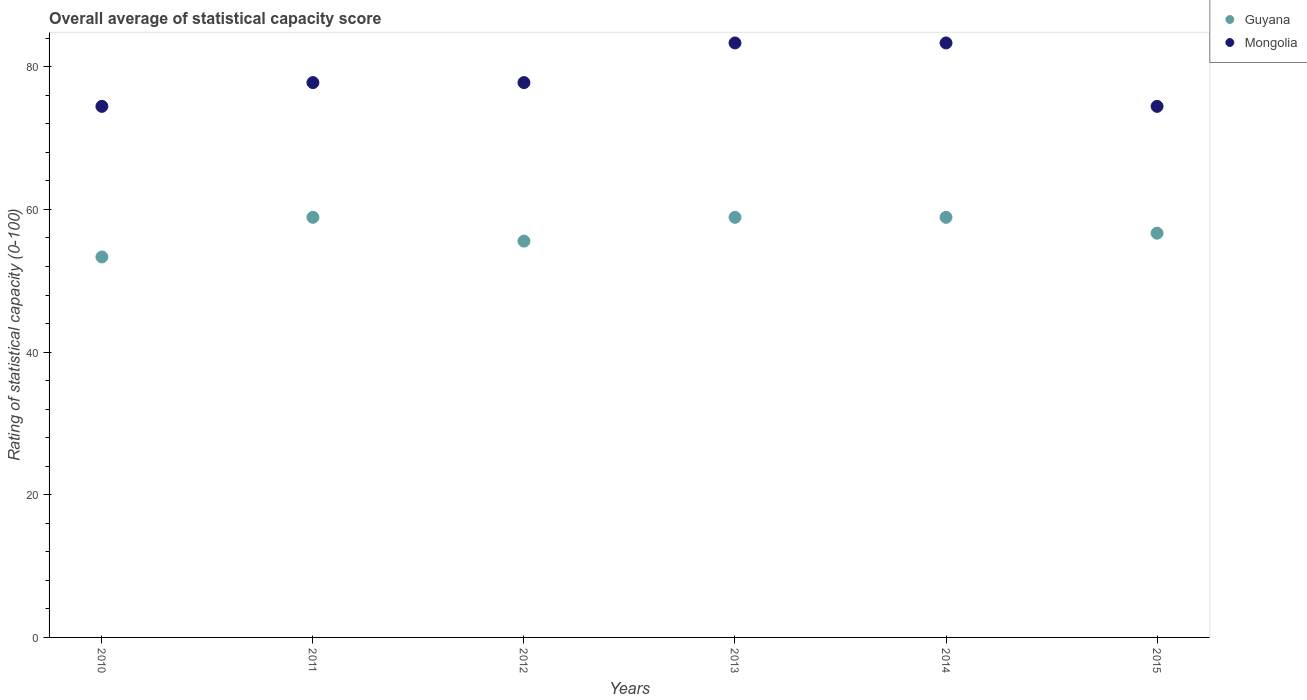What is the rating of statistical capacity in Mongolia in 2014?
Your response must be concise. 83.33. Across all years, what is the maximum rating of statistical capacity in Mongolia?
Keep it short and to the point. 83.33. Across all years, what is the minimum rating of statistical capacity in Mongolia?
Your answer should be very brief. 74.44. What is the total rating of statistical capacity in Mongolia in the graph?
Offer a very short reply. 471.11. What is the difference between the rating of statistical capacity in Guyana in 2010 and that in 2014?
Offer a very short reply. -5.56. What is the difference between the rating of statistical capacity in Guyana in 2011 and the rating of statistical capacity in Mongolia in 2012?
Make the answer very short. -18.89. What is the average rating of statistical capacity in Guyana per year?
Provide a short and direct response. 57.04. In the year 2012, what is the difference between the rating of statistical capacity in Mongolia and rating of statistical capacity in Guyana?
Ensure brevity in your answer.  22.22. What is the ratio of the rating of statistical capacity in Mongolia in 2014 to that in 2015?
Provide a short and direct response. 1.12. Is the rating of statistical capacity in Guyana in 2014 less than that in 2015?
Make the answer very short. No. Is the difference between the rating of statistical capacity in Mongolia in 2012 and 2014 greater than the difference between the rating of statistical capacity in Guyana in 2012 and 2014?
Keep it short and to the point. No. What is the difference between the highest and the second highest rating of statistical capacity in Mongolia?
Ensure brevity in your answer.  0. What is the difference between the highest and the lowest rating of statistical capacity in Mongolia?
Offer a terse response. 8.89. In how many years, is the rating of statistical capacity in Guyana greater than the average rating of statistical capacity in Guyana taken over all years?
Keep it short and to the point. 3. Is the sum of the rating of statistical capacity in Guyana in 2012 and 2015 greater than the maximum rating of statistical capacity in Mongolia across all years?
Offer a very short reply. Yes. Does the rating of statistical capacity in Mongolia monotonically increase over the years?
Your answer should be compact. No. Is the rating of statistical capacity in Guyana strictly less than the rating of statistical capacity in Mongolia over the years?
Your answer should be compact. Yes. How many dotlines are there?
Ensure brevity in your answer.  2. How many years are there in the graph?
Offer a very short reply. 6. Does the graph contain grids?
Your answer should be compact. No. How many legend labels are there?
Your answer should be very brief. 2. What is the title of the graph?
Give a very brief answer. Overall average of statistical capacity score. What is the label or title of the Y-axis?
Give a very brief answer. Rating of statistical capacity (0-100). What is the Rating of statistical capacity (0-100) of Guyana in 2010?
Your answer should be very brief. 53.33. What is the Rating of statistical capacity (0-100) in Mongolia in 2010?
Provide a succinct answer. 74.44. What is the Rating of statistical capacity (0-100) of Guyana in 2011?
Your answer should be very brief. 58.89. What is the Rating of statistical capacity (0-100) of Mongolia in 2011?
Ensure brevity in your answer.  77.78. What is the Rating of statistical capacity (0-100) of Guyana in 2012?
Your response must be concise. 55.56. What is the Rating of statistical capacity (0-100) in Mongolia in 2012?
Provide a succinct answer. 77.78. What is the Rating of statistical capacity (0-100) in Guyana in 2013?
Keep it short and to the point. 58.89. What is the Rating of statistical capacity (0-100) in Mongolia in 2013?
Provide a succinct answer. 83.33. What is the Rating of statistical capacity (0-100) of Guyana in 2014?
Your answer should be very brief. 58.89. What is the Rating of statistical capacity (0-100) in Mongolia in 2014?
Ensure brevity in your answer.  83.33. What is the Rating of statistical capacity (0-100) in Guyana in 2015?
Make the answer very short. 56.67. What is the Rating of statistical capacity (0-100) of Mongolia in 2015?
Make the answer very short. 74.44. Across all years, what is the maximum Rating of statistical capacity (0-100) of Guyana?
Your response must be concise. 58.89. Across all years, what is the maximum Rating of statistical capacity (0-100) in Mongolia?
Give a very brief answer. 83.33. Across all years, what is the minimum Rating of statistical capacity (0-100) in Guyana?
Your response must be concise. 53.33. Across all years, what is the minimum Rating of statistical capacity (0-100) of Mongolia?
Provide a short and direct response. 74.44. What is the total Rating of statistical capacity (0-100) in Guyana in the graph?
Your answer should be compact. 342.22. What is the total Rating of statistical capacity (0-100) in Mongolia in the graph?
Offer a terse response. 471.11. What is the difference between the Rating of statistical capacity (0-100) of Guyana in 2010 and that in 2011?
Offer a very short reply. -5.56. What is the difference between the Rating of statistical capacity (0-100) of Mongolia in 2010 and that in 2011?
Offer a very short reply. -3.33. What is the difference between the Rating of statistical capacity (0-100) in Guyana in 2010 and that in 2012?
Ensure brevity in your answer.  -2.22. What is the difference between the Rating of statistical capacity (0-100) in Mongolia in 2010 and that in 2012?
Your answer should be compact. -3.33. What is the difference between the Rating of statistical capacity (0-100) in Guyana in 2010 and that in 2013?
Your answer should be very brief. -5.56. What is the difference between the Rating of statistical capacity (0-100) in Mongolia in 2010 and that in 2013?
Provide a succinct answer. -8.89. What is the difference between the Rating of statistical capacity (0-100) in Guyana in 2010 and that in 2014?
Give a very brief answer. -5.56. What is the difference between the Rating of statistical capacity (0-100) of Mongolia in 2010 and that in 2014?
Give a very brief answer. -8.89. What is the difference between the Rating of statistical capacity (0-100) in Guyana in 2010 and that in 2015?
Provide a succinct answer. -3.33. What is the difference between the Rating of statistical capacity (0-100) of Mongolia in 2010 and that in 2015?
Offer a terse response. 0. What is the difference between the Rating of statistical capacity (0-100) in Guyana in 2011 and that in 2012?
Keep it short and to the point. 3.33. What is the difference between the Rating of statistical capacity (0-100) in Mongolia in 2011 and that in 2012?
Offer a very short reply. 0. What is the difference between the Rating of statistical capacity (0-100) of Mongolia in 2011 and that in 2013?
Ensure brevity in your answer.  -5.56. What is the difference between the Rating of statistical capacity (0-100) of Mongolia in 2011 and that in 2014?
Keep it short and to the point. -5.56. What is the difference between the Rating of statistical capacity (0-100) in Guyana in 2011 and that in 2015?
Provide a succinct answer. 2.22. What is the difference between the Rating of statistical capacity (0-100) of Mongolia in 2011 and that in 2015?
Make the answer very short. 3.33. What is the difference between the Rating of statistical capacity (0-100) of Guyana in 2012 and that in 2013?
Offer a very short reply. -3.33. What is the difference between the Rating of statistical capacity (0-100) of Mongolia in 2012 and that in 2013?
Keep it short and to the point. -5.56. What is the difference between the Rating of statistical capacity (0-100) in Mongolia in 2012 and that in 2014?
Give a very brief answer. -5.56. What is the difference between the Rating of statistical capacity (0-100) of Guyana in 2012 and that in 2015?
Provide a short and direct response. -1.11. What is the difference between the Rating of statistical capacity (0-100) of Mongolia in 2012 and that in 2015?
Ensure brevity in your answer.  3.33. What is the difference between the Rating of statistical capacity (0-100) of Guyana in 2013 and that in 2015?
Offer a terse response. 2.22. What is the difference between the Rating of statistical capacity (0-100) in Mongolia in 2013 and that in 2015?
Make the answer very short. 8.89. What is the difference between the Rating of statistical capacity (0-100) of Guyana in 2014 and that in 2015?
Keep it short and to the point. 2.22. What is the difference between the Rating of statistical capacity (0-100) in Mongolia in 2014 and that in 2015?
Keep it short and to the point. 8.89. What is the difference between the Rating of statistical capacity (0-100) in Guyana in 2010 and the Rating of statistical capacity (0-100) in Mongolia in 2011?
Provide a short and direct response. -24.44. What is the difference between the Rating of statistical capacity (0-100) in Guyana in 2010 and the Rating of statistical capacity (0-100) in Mongolia in 2012?
Offer a very short reply. -24.44. What is the difference between the Rating of statistical capacity (0-100) in Guyana in 2010 and the Rating of statistical capacity (0-100) in Mongolia in 2013?
Provide a succinct answer. -30. What is the difference between the Rating of statistical capacity (0-100) in Guyana in 2010 and the Rating of statistical capacity (0-100) in Mongolia in 2015?
Your answer should be very brief. -21.11. What is the difference between the Rating of statistical capacity (0-100) of Guyana in 2011 and the Rating of statistical capacity (0-100) of Mongolia in 2012?
Your response must be concise. -18.89. What is the difference between the Rating of statistical capacity (0-100) in Guyana in 2011 and the Rating of statistical capacity (0-100) in Mongolia in 2013?
Provide a succinct answer. -24.44. What is the difference between the Rating of statistical capacity (0-100) of Guyana in 2011 and the Rating of statistical capacity (0-100) of Mongolia in 2014?
Keep it short and to the point. -24.44. What is the difference between the Rating of statistical capacity (0-100) of Guyana in 2011 and the Rating of statistical capacity (0-100) of Mongolia in 2015?
Offer a terse response. -15.56. What is the difference between the Rating of statistical capacity (0-100) in Guyana in 2012 and the Rating of statistical capacity (0-100) in Mongolia in 2013?
Keep it short and to the point. -27.78. What is the difference between the Rating of statistical capacity (0-100) in Guyana in 2012 and the Rating of statistical capacity (0-100) in Mongolia in 2014?
Your answer should be compact. -27.78. What is the difference between the Rating of statistical capacity (0-100) in Guyana in 2012 and the Rating of statistical capacity (0-100) in Mongolia in 2015?
Provide a short and direct response. -18.89. What is the difference between the Rating of statistical capacity (0-100) of Guyana in 2013 and the Rating of statistical capacity (0-100) of Mongolia in 2014?
Your response must be concise. -24.44. What is the difference between the Rating of statistical capacity (0-100) of Guyana in 2013 and the Rating of statistical capacity (0-100) of Mongolia in 2015?
Offer a very short reply. -15.56. What is the difference between the Rating of statistical capacity (0-100) of Guyana in 2014 and the Rating of statistical capacity (0-100) of Mongolia in 2015?
Ensure brevity in your answer.  -15.56. What is the average Rating of statistical capacity (0-100) in Guyana per year?
Provide a succinct answer. 57.04. What is the average Rating of statistical capacity (0-100) in Mongolia per year?
Provide a succinct answer. 78.52. In the year 2010, what is the difference between the Rating of statistical capacity (0-100) in Guyana and Rating of statistical capacity (0-100) in Mongolia?
Ensure brevity in your answer.  -21.11. In the year 2011, what is the difference between the Rating of statistical capacity (0-100) of Guyana and Rating of statistical capacity (0-100) of Mongolia?
Ensure brevity in your answer.  -18.89. In the year 2012, what is the difference between the Rating of statistical capacity (0-100) in Guyana and Rating of statistical capacity (0-100) in Mongolia?
Provide a short and direct response. -22.22. In the year 2013, what is the difference between the Rating of statistical capacity (0-100) in Guyana and Rating of statistical capacity (0-100) in Mongolia?
Your response must be concise. -24.44. In the year 2014, what is the difference between the Rating of statistical capacity (0-100) of Guyana and Rating of statistical capacity (0-100) of Mongolia?
Make the answer very short. -24.44. In the year 2015, what is the difference between the Rating of statistical capacity (0-100) in Guyana and Rating of statistical capacity (0-100) in Mongolia?
Your answer should be compact. -17.78. What is the ratio of the Rating of statistical capacity (0-100) in Guyana in 2010 to that in 2011?
Provide a short and direct response. 0.91. What is the ratio of the Rating of statistical capacity (0-100) of Mongolia in 2010 to that in 2011?
Ensure brevity in your answer.  0.96. What is the ratio of the Rating of statistical capacity (0-100) in Guyana in 2010 to that in 2012?
Your answer should be compact. 0.96. What is the ratio of the Rating of statistical capacity (0-100) in Mongolia in 2010 to that in 2012?
Offer a terse response. 0.96. What is the ratio of the Rating of statistical capacity (0-100) of Guyana in 2010 to that in 2013?
Offer a terse response. 0.91. What is the ratio of the Rating of statistical capacity (0-100) of Mongolia in 2010 to that in 2013?
Ensure brevity in your answer.  0.89. What is the ratio of the Rating of statistical capacity (0-100) in Guyana in 2010 to that in 2014?
Offer a terse response. 0.91. What is the ratio of the Rating of statistical capacity (0-100) in Mongolia in 2010 to that in 2014?
Offer a very short reply. 0.89. What is the ratio of the Rating of statistical capacity (0-100) of Guyana in 2010 to that in 2015?
Your response must be concise. 0.94. What is the ratio of the Rating of statistical capacity (0-100) of Guyana in 2011 to that in 2012?
Ensure brevity in your answer.  1.06. What is the ratio of the Rating of statistical capacity (0-100) in Mongolia in 2011 to that in 2014?
Ensure brevity in your answer.  0.93. What is the ratio of the Rating of statistical capacity (0-100) in Guyana in 2011 to that in 2015?
Provide a succinct answer. 1.04. What is the ratio of the Rating of statistical capacity (0-100) in Mongolia in 2011 to that in 2015?
Your answer should be very brief. 1.04. What is the ratio of the Rating of statistical capacity (0-100) in Guyana in 2012 to that in 2013?
Provide a short and direct response. 0.94. What is the ratio of the Rating of statistical capacity (0-100) in Mongolia in 2012 to that in 2013?
Keep it short and to the point. 0.93. What is the ratio of the Rating of statistical capacity (0-100) in Guyana in 2012 to that in 2014?
Provide a short and direct response. 0.94. What is the ratio of the Rating of statistical capacity (0-100) in Guyana in 2012 to that in 2015?
Offer a very short reply. 0.98. What is the ratio of the Rating of statistical capacity (0-100) in Mongolia in 2012 to that in 2015?
Offer a very short reply. 1.04. What is the ratio of the Rating of statistical capacity (0-100) in Guyana in 2013 to that in 2015?
Your answer should be very brief. 1.04. What is the ratio of the Rating of statistical capacity (0-100) of Mongolia in 2013 to that in 2015?
Your answer should be very brief. 1.12. What is the ratio of the Rating of statistical capacity (0-100) in Guyana in 2014 to that in 2015?
Make the answer very short. 1.04. What is the ratio of the Rating of statistical capacity (0-100) in Mongolia in 2014 to that in 2015?
Offer a terse response. 1.12. What is the difference between the highest and the second highest Rating of statistical capacity (0-100) of Mongolia?
Your response must be concise. 0. What is the difference between the highest and the lowest Rating of statistical capacity (0-100) of Guyana?
Your answer should be very brief. 5.56. What is the difference between the highest and the lowest Rating of statistical capacity (0-100) of Mongolia?
Provide a succinct answer. 8.89. 